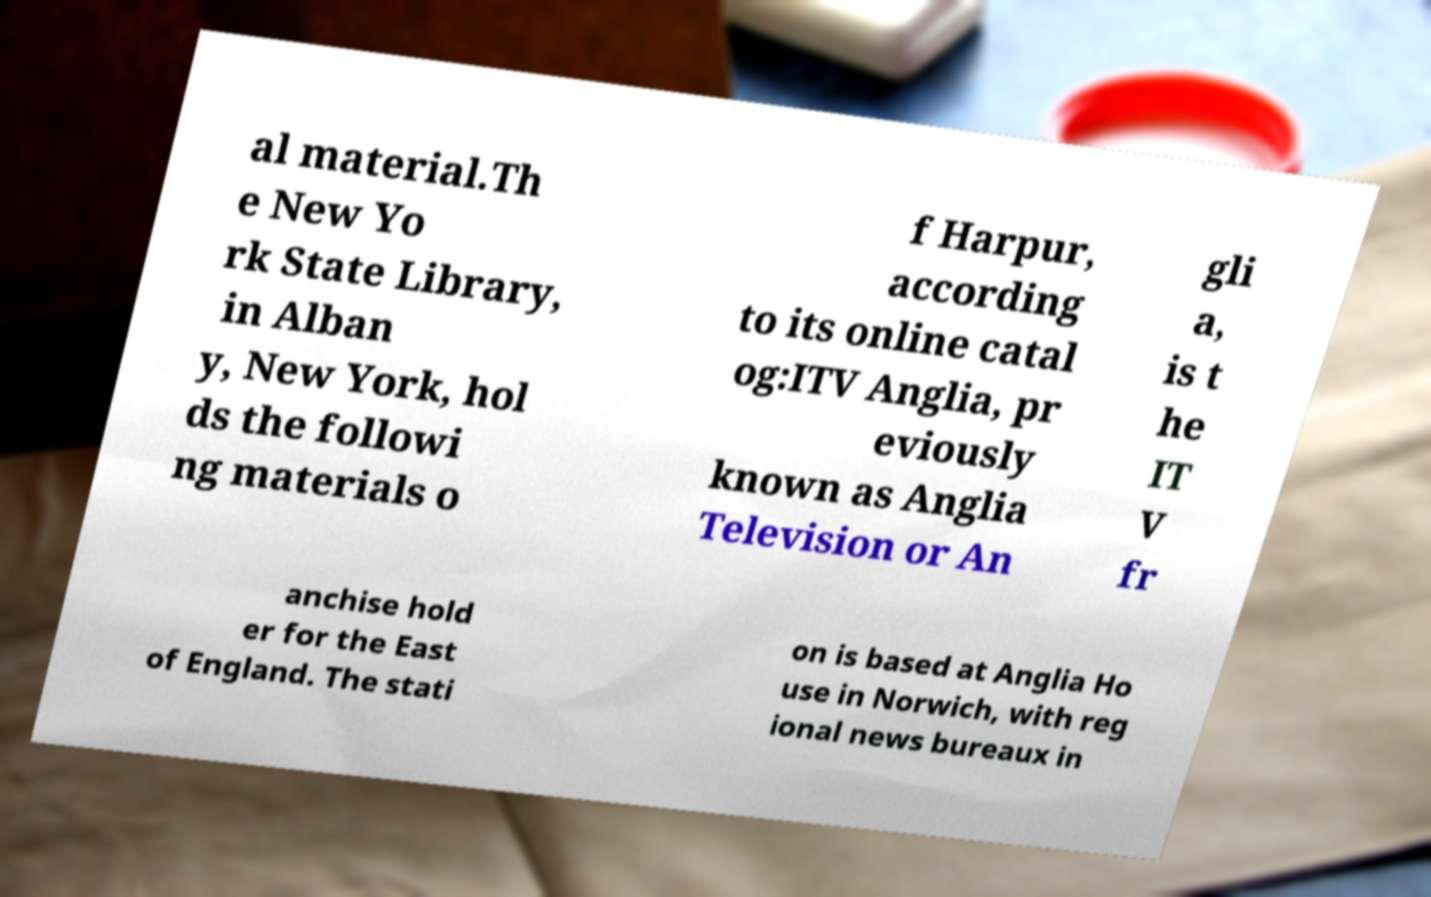What messages or text are displayed in this image? I need them in a readable, typed format. al material.Th e New Yo rk State Library, in Alban y, New York, hol ds the followi ng materials o f Harpur, according to its online catal og:ITV Anglia, pr eviously known as Anglia Television or An gli a, is t he IT V fr anchise hold er for the East of England. The stati on is based at Anglia Ho use in Norwich, with reg ional news bureaux in 